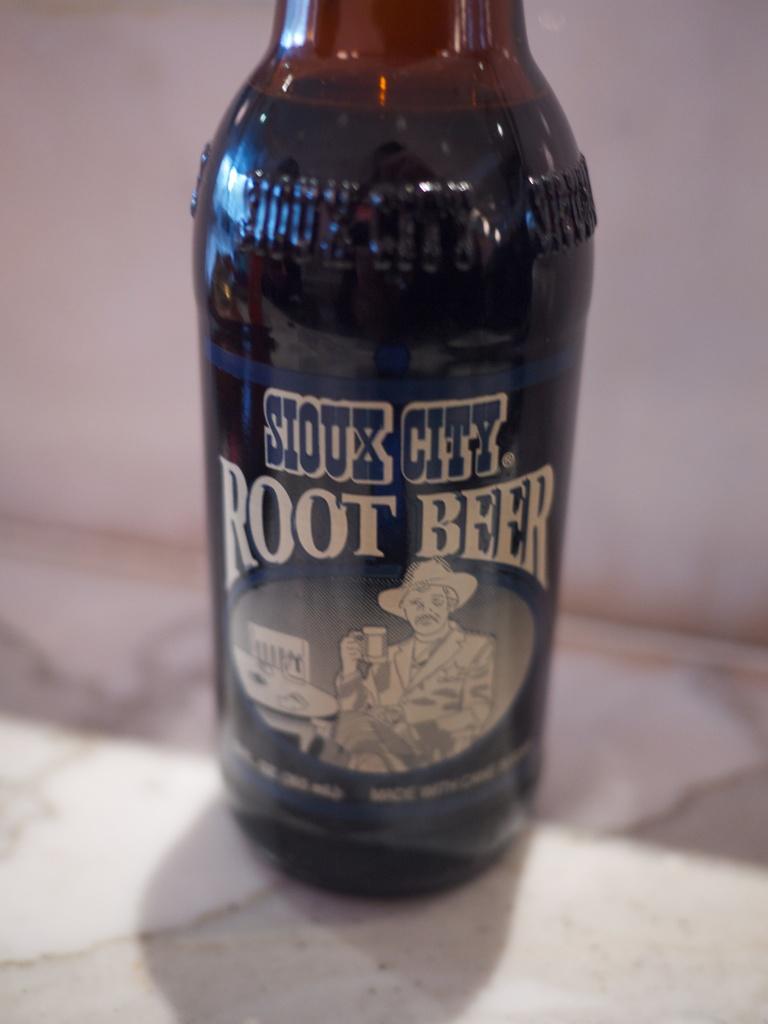Is this a beer or a soda type of liquid?
Ensure brevity in your answer.  Root beer. What is the city?
Provide a short and direct response. Sioux city. 